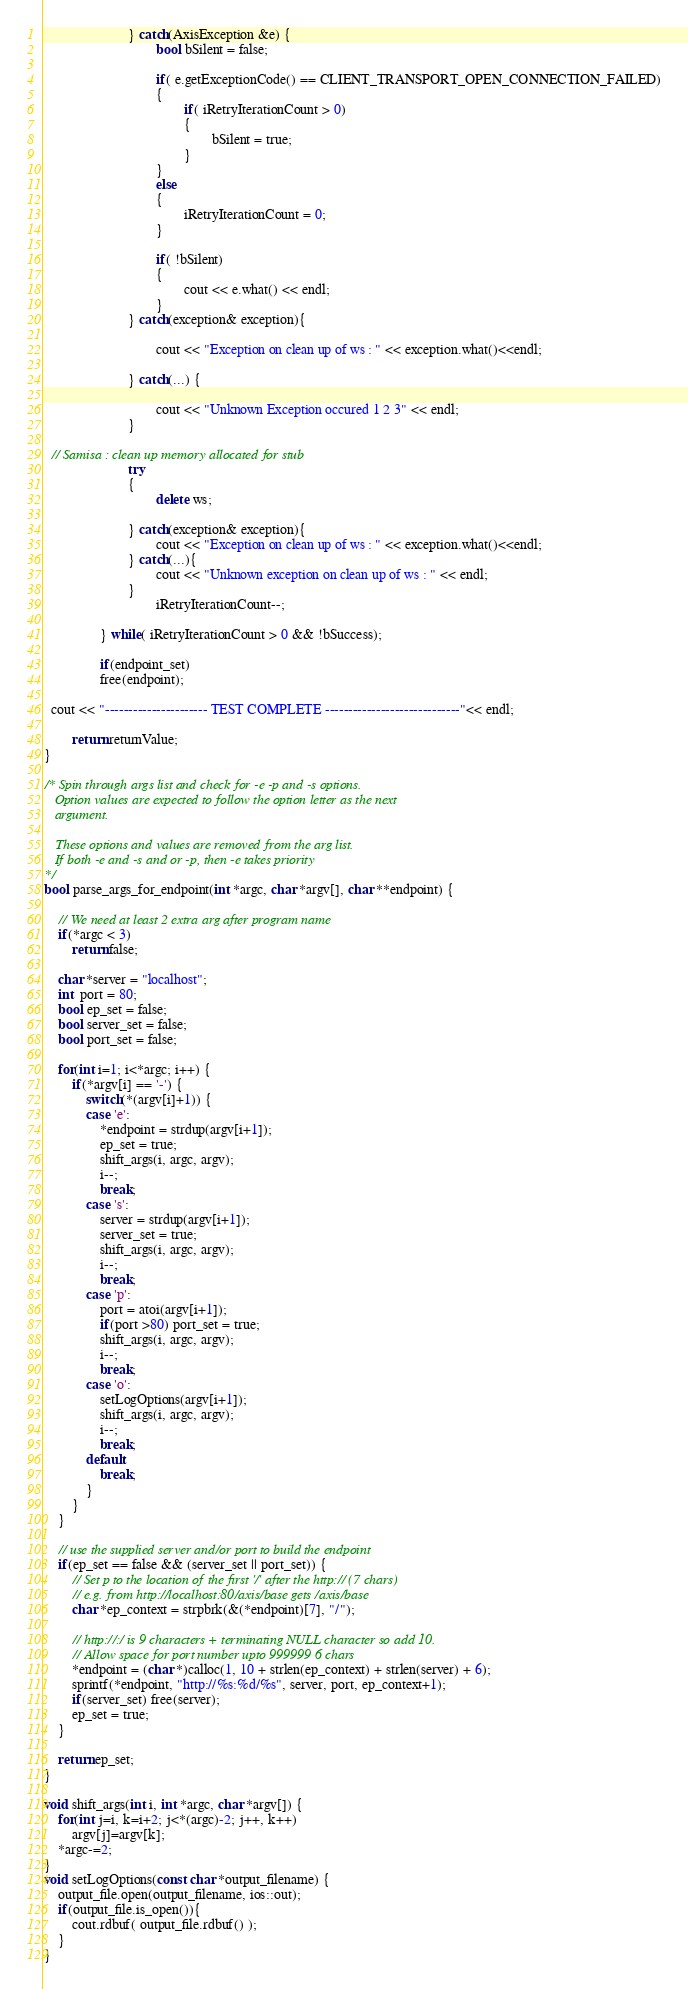<code> <loc_0><loc_0><loc_500><loc_500><_C++_>
                        } catch(AxisException &e) {
                                bool bSilent = false;

                                if( e.getExceptionCode() == CLIENT_TRANSPORT_OPEN_CONNECTION_FAILED)
                                {
                                        if( iRetryIterationCount > 0)
                                        {
                                                bSilent = true;
                                        }
                                }
                                else
                                {
                                        iRetryIterationCount = 0;
                                }

                                if( !bSilent)
                                {
                                        cout << e.what() << endl;
                                }
                        } catch(exception& exception){

                                cout << "Exception on clean up of ws : " << exception.what()<<endl;
                
                        } catch(...) {
                                
                                cout << "Unknown Exception occured 1 2 3" << endl;
                        }  
  
  // Samisa : clean up memory allocated for stub
                        try
                        {
                                delete ws; 

                        } catch(exception& exception){
                                cout << "Exception on clean up of ws : " << exception.what()<<endl;
                        } catch(...){
                                cout << "Unknown exception on clean up of ws : " << endl;
                        } 
                                iRetryIterationCount--;

                } while( iRetryIterationCount > 0 && !bSuccess);

                if(endpoint_set)
                free(endpoint);

  cout << "---------------------- TEST COMPLETE -----------------------------"<< endl;

        return returnValue;
}

/* Spin through args list and check for -e -p and -s options.
   Option values are expected to follow the option letter as the next
   argument.
 
   These options and values are removed from the arg list.
   If both -e and -s and or -p, then -e takes priority
*/
bool parse_args_for_endpoint(int *argc, char *argv[], char **endpoint) {

    // We need at least 2 extra arg after program name
    if(*argc < 3)
        return false;

    char *server = "localhost";
    int  port = 80;
    bool ep_set = false;
    bool server_set = false;
    bool port_set = false;

    for(int i=1; i<*argc; i++) {
        if(*argv[i] == '-') {
            switch(*(argv[i]+1)) {
            case 'e':
                *endpoint = strdup(argv[i+1]);
                ep_set = true;
                shift_args(i, argc, argv);
                i--;
                break;
            case 's':
                server = strdup(argv[i+1]);
                server_set = true;
                shift_args(i, argc, argv);
                i--;
                break;
            case 'p':
                port = atoi(argv[i+1]);
                if(port >80) port_set = true;
                shift_args(i, argc, argv);
                i--;
                break;
            case 'o':
                setLogOptions(argv[i+1]);
                shift_args(i, argc, argv);
                i--;
                break;
            default:
                break;
            }
        }
    }

    // use the supplied server and/or port to build the endpoint
    if(ep_set == false && (server_set || port_set)) {
        // Set p to the location of the first '/' after the http:// (7 chars)
        // e.g. from http://localhost:80/axis/base gets /axis/base
        char *ep_context = strpbrk(&(*endpoint)[7], "/");

        // http://:/ is 9 characters + terminating NULL character so add 10.
        // Allow space for port number upto 999999 6 chars
        *endpoint = (char *)calloc(1, 10 + strlen(ep_context) + strlen(server) + 6);
        sprintf(*endpoint, "http://%s:%d/%s", server, port, ep_context+1);
        if(server_set) free(server);
        ep_set = true;
    }

    return ep_set;
}

void shift_args(int i, int *argc, char *argv[]) {
    for(int j=i, k=i+2; j<*(argc)-2; j++, k++)
        argv[j]=argv[k];
    *argc-=2;
}
void setLogOptions(const char *output_filename) {
    output_file.open(output_filename, ios::out);
    if(output_file.is_open()){
        cout.rdbuf( output_file.rdbuf() );
    }
}</code> 